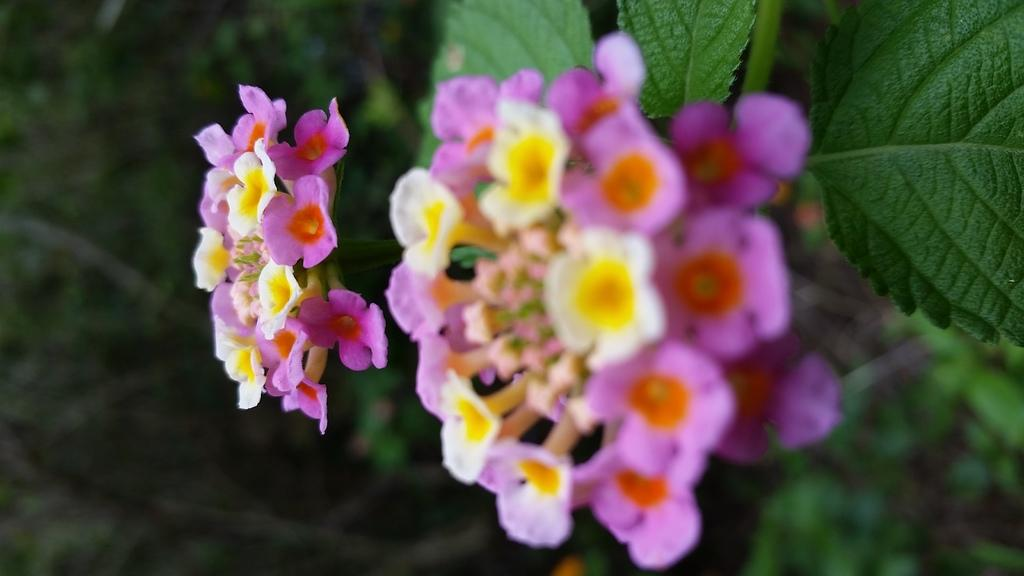What types of plants are present in the image? There are flowers of different colors in the image. What else can be seen on the plants in the image? There are leaves visible in the image. Can you describe the quality of the image on the left side? The left side of the image is blurred. What news headline is visible on the flowers in the image? There is no news headline present in the image; it features flowers and leaves. What invention can be seen in the image? There is no invention visible in the image; it only contains flowers and leaves. 